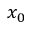<formula> <loc_0><loc_0><loc_500><loc_500>x _ { 0 }</formula> 